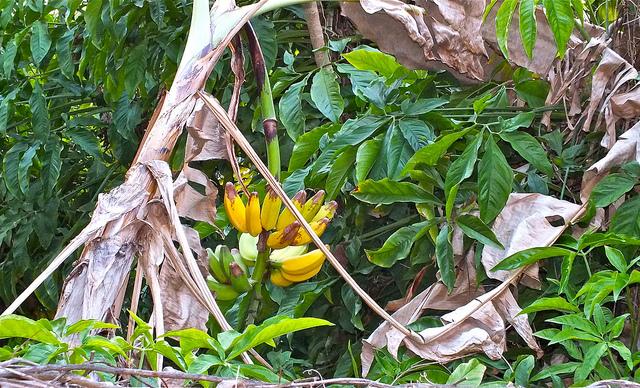Are the bananas ripe?
Answer briefly. Yes. What color are the bananas?
Concise answer only. Yellow. Are the bananas ready to eat?
Concise answer only. Yes. What are green in the picture?
Quick response, please. Leaves. Are these bananas ripe?
Be succinct. Yes. Is this a garden?
Short answer required. No. 